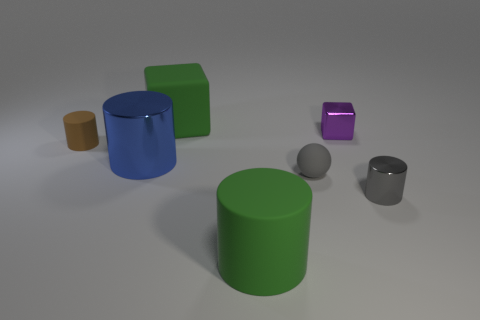Add 2 big green cubes. How many objects exist? 9 Subtract all cylinders. How many objects are left? 3 Add 4 small blocks. How many small blocks exist? 5 Subtract 1 brown cylinders. How many objects are left? 6 Subtract all small yellow rubber balls. Subtract all brown rubber cylinders. How many objects are left? 6 Add 4 large green rubber cylinders. How many large green rubber cylinders are left? 5 